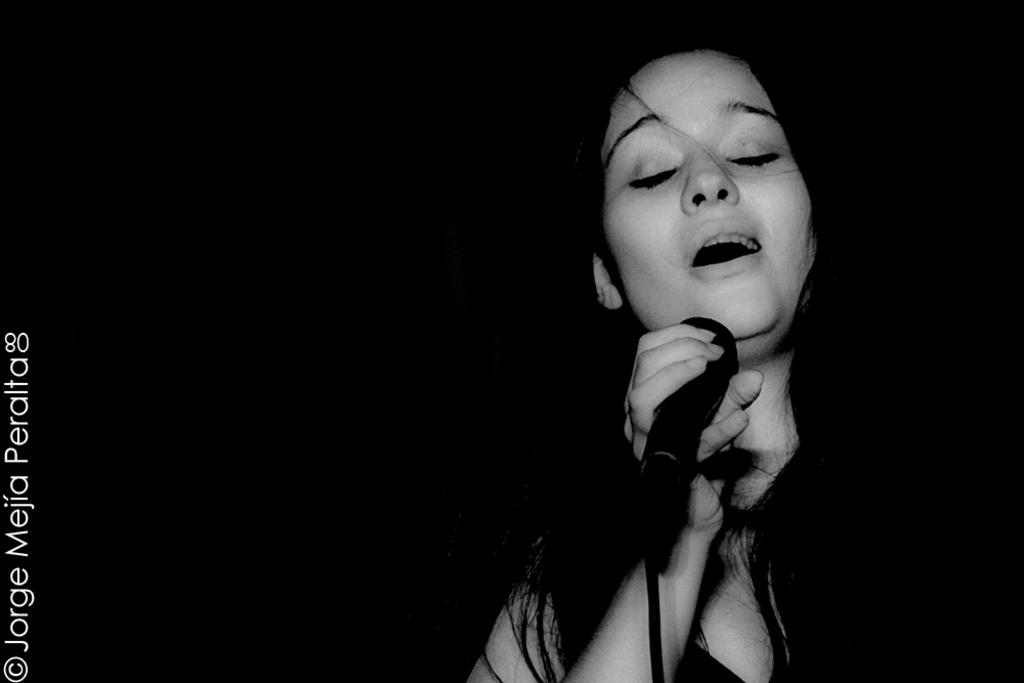Who is the main subject in the image? There is a girl in the image. the image. Where is the girl positioned in the image? The girl is standing on the right side. What is the girl holding in the image? The girl is holding a microphone. What can be inferred about the color of the microphone? The microphone is black in color. What is the girl doing with the microphone? The girl is singing into the microphone. What news does the girl regret sharing through the microphone in the image? There is no indication in the image that the girl is sharing any news, nor is there any mention of regret. 